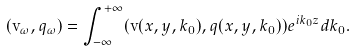<formula> <loc_0><loc_0><loc_500><loc_500>( { \mathbf v } _ { \omega } , q _ { \omega } ) = \int _ { - \infty } ^ { + \infty } ( { \mathbf v } ( x , y , k _ { 0 } ) , q ( x , y , k _ { 0 } ) ) e ^ { i k _ { 0 } z } d k _ { 0 } .</formula> 